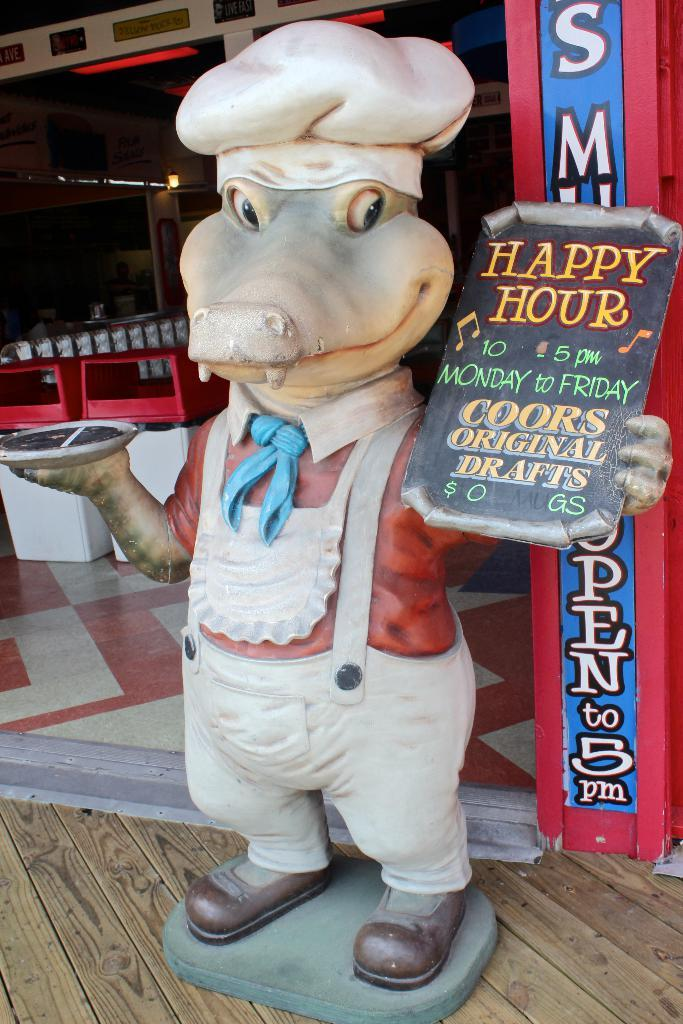What type of toy is in the picture? There is a toy crocodile in the picture. What is the toy crocodile wearing? The toy crocodile is wearing an apron and a hat. What is the toy crocodile holding? The toy crocodile is holding a board and a plate. What can be seen in the backdrop of the picture? There are chairs, a banner, and a table in the backdrop of the picture. Can you tell me how many cards the toy crocodile is holding in the picture? There is no card present in the picture; the toy crocodile is holding a board and a plate. Is there any indication that the toy crocodile is about to get a haircut in the picture? There is no indication of a haircut or any grooming activity in the picture. 